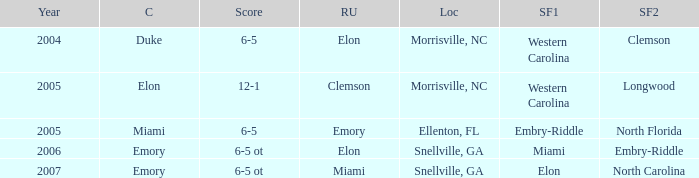Where was the final game played in 2007 Snellville, GA. 